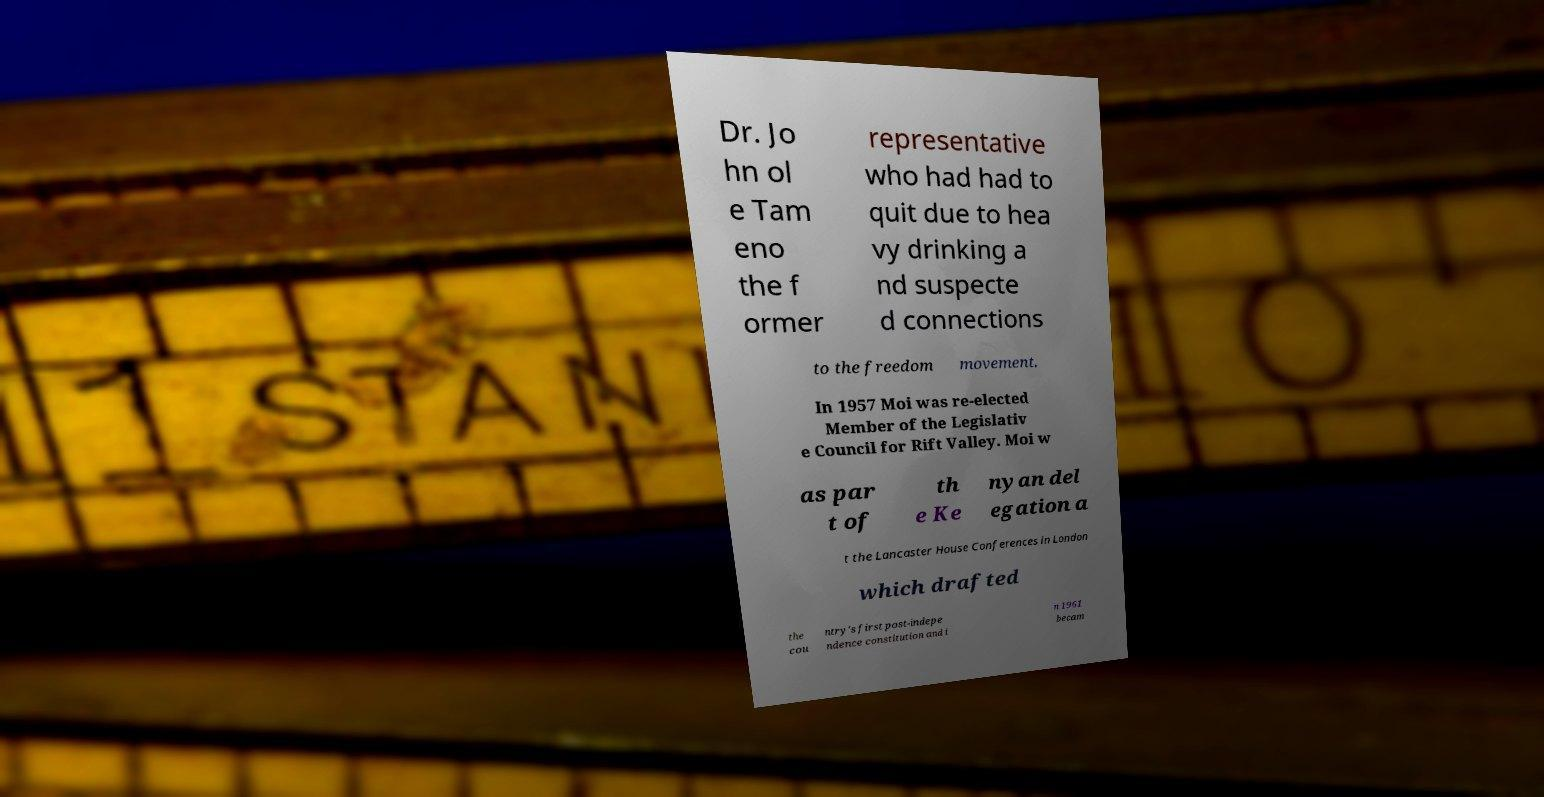Please read and relay the text visible in this image. What does it say? Dr. Jo hn ol e Tam eno the f ormer representative who had had to quit due to hea vy drinking a nd suspecte d connections to the freedom movement. In 1957 Moi was re-elected Member of the Legislativ e Council for Rift Valley. Moi w as par t of th e Ke nyan del egation a t the Lancaster House Conferences in London which drafted the cou ntry's first post-indepe ndence constitution and i n 1961 becam 